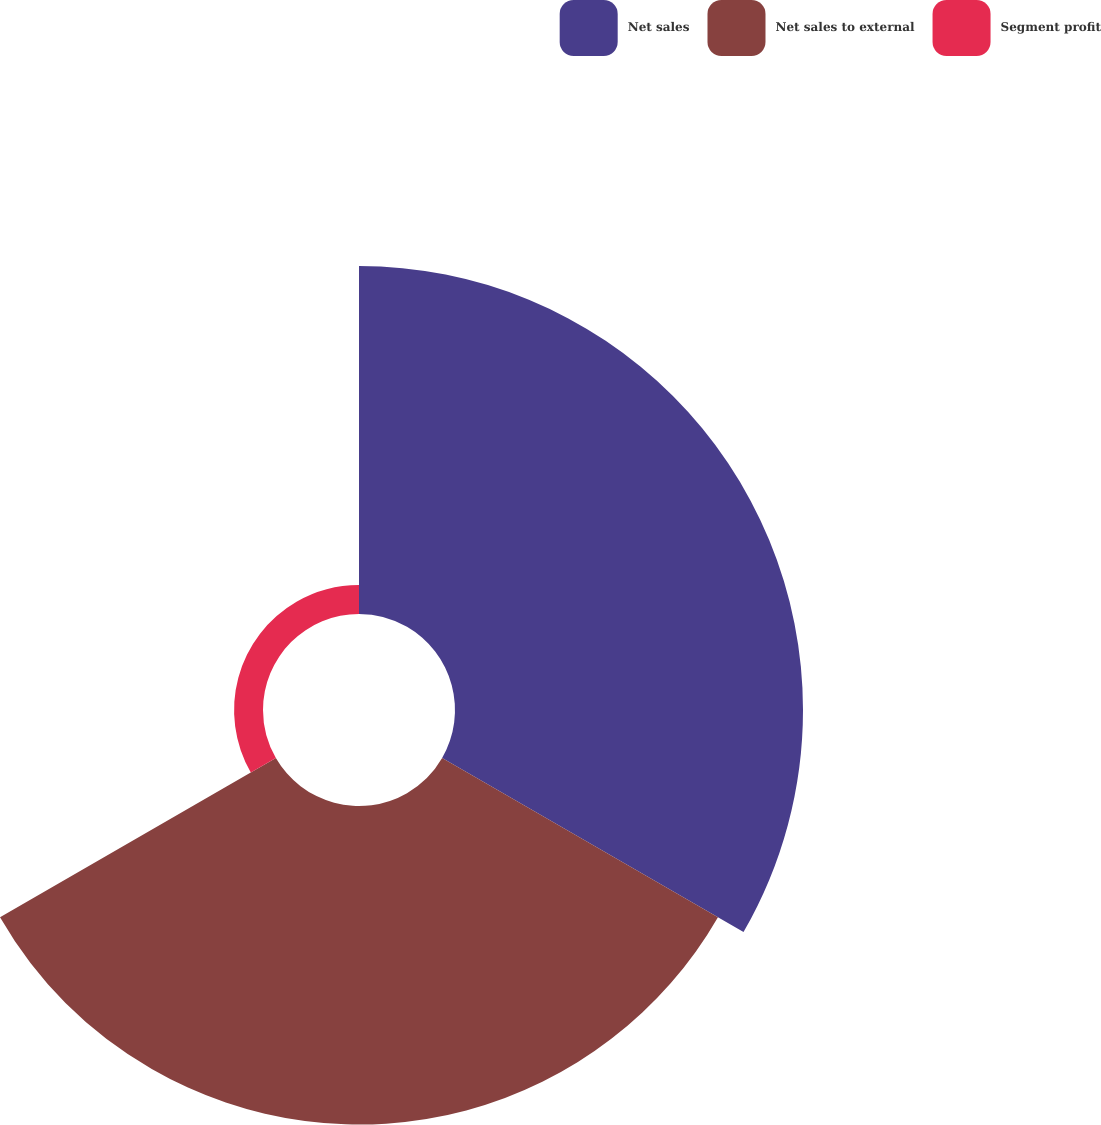Convert chart to OTSL. <chart><loc_0><loc_0><loc_500><loc_500><pie_chart><fcel>Net sales<fcel>Net sales to external<fcel>Segment profit<nl><fcel>50.04%<fcel>45.8%<fcel>4.16%<nl></chart> 